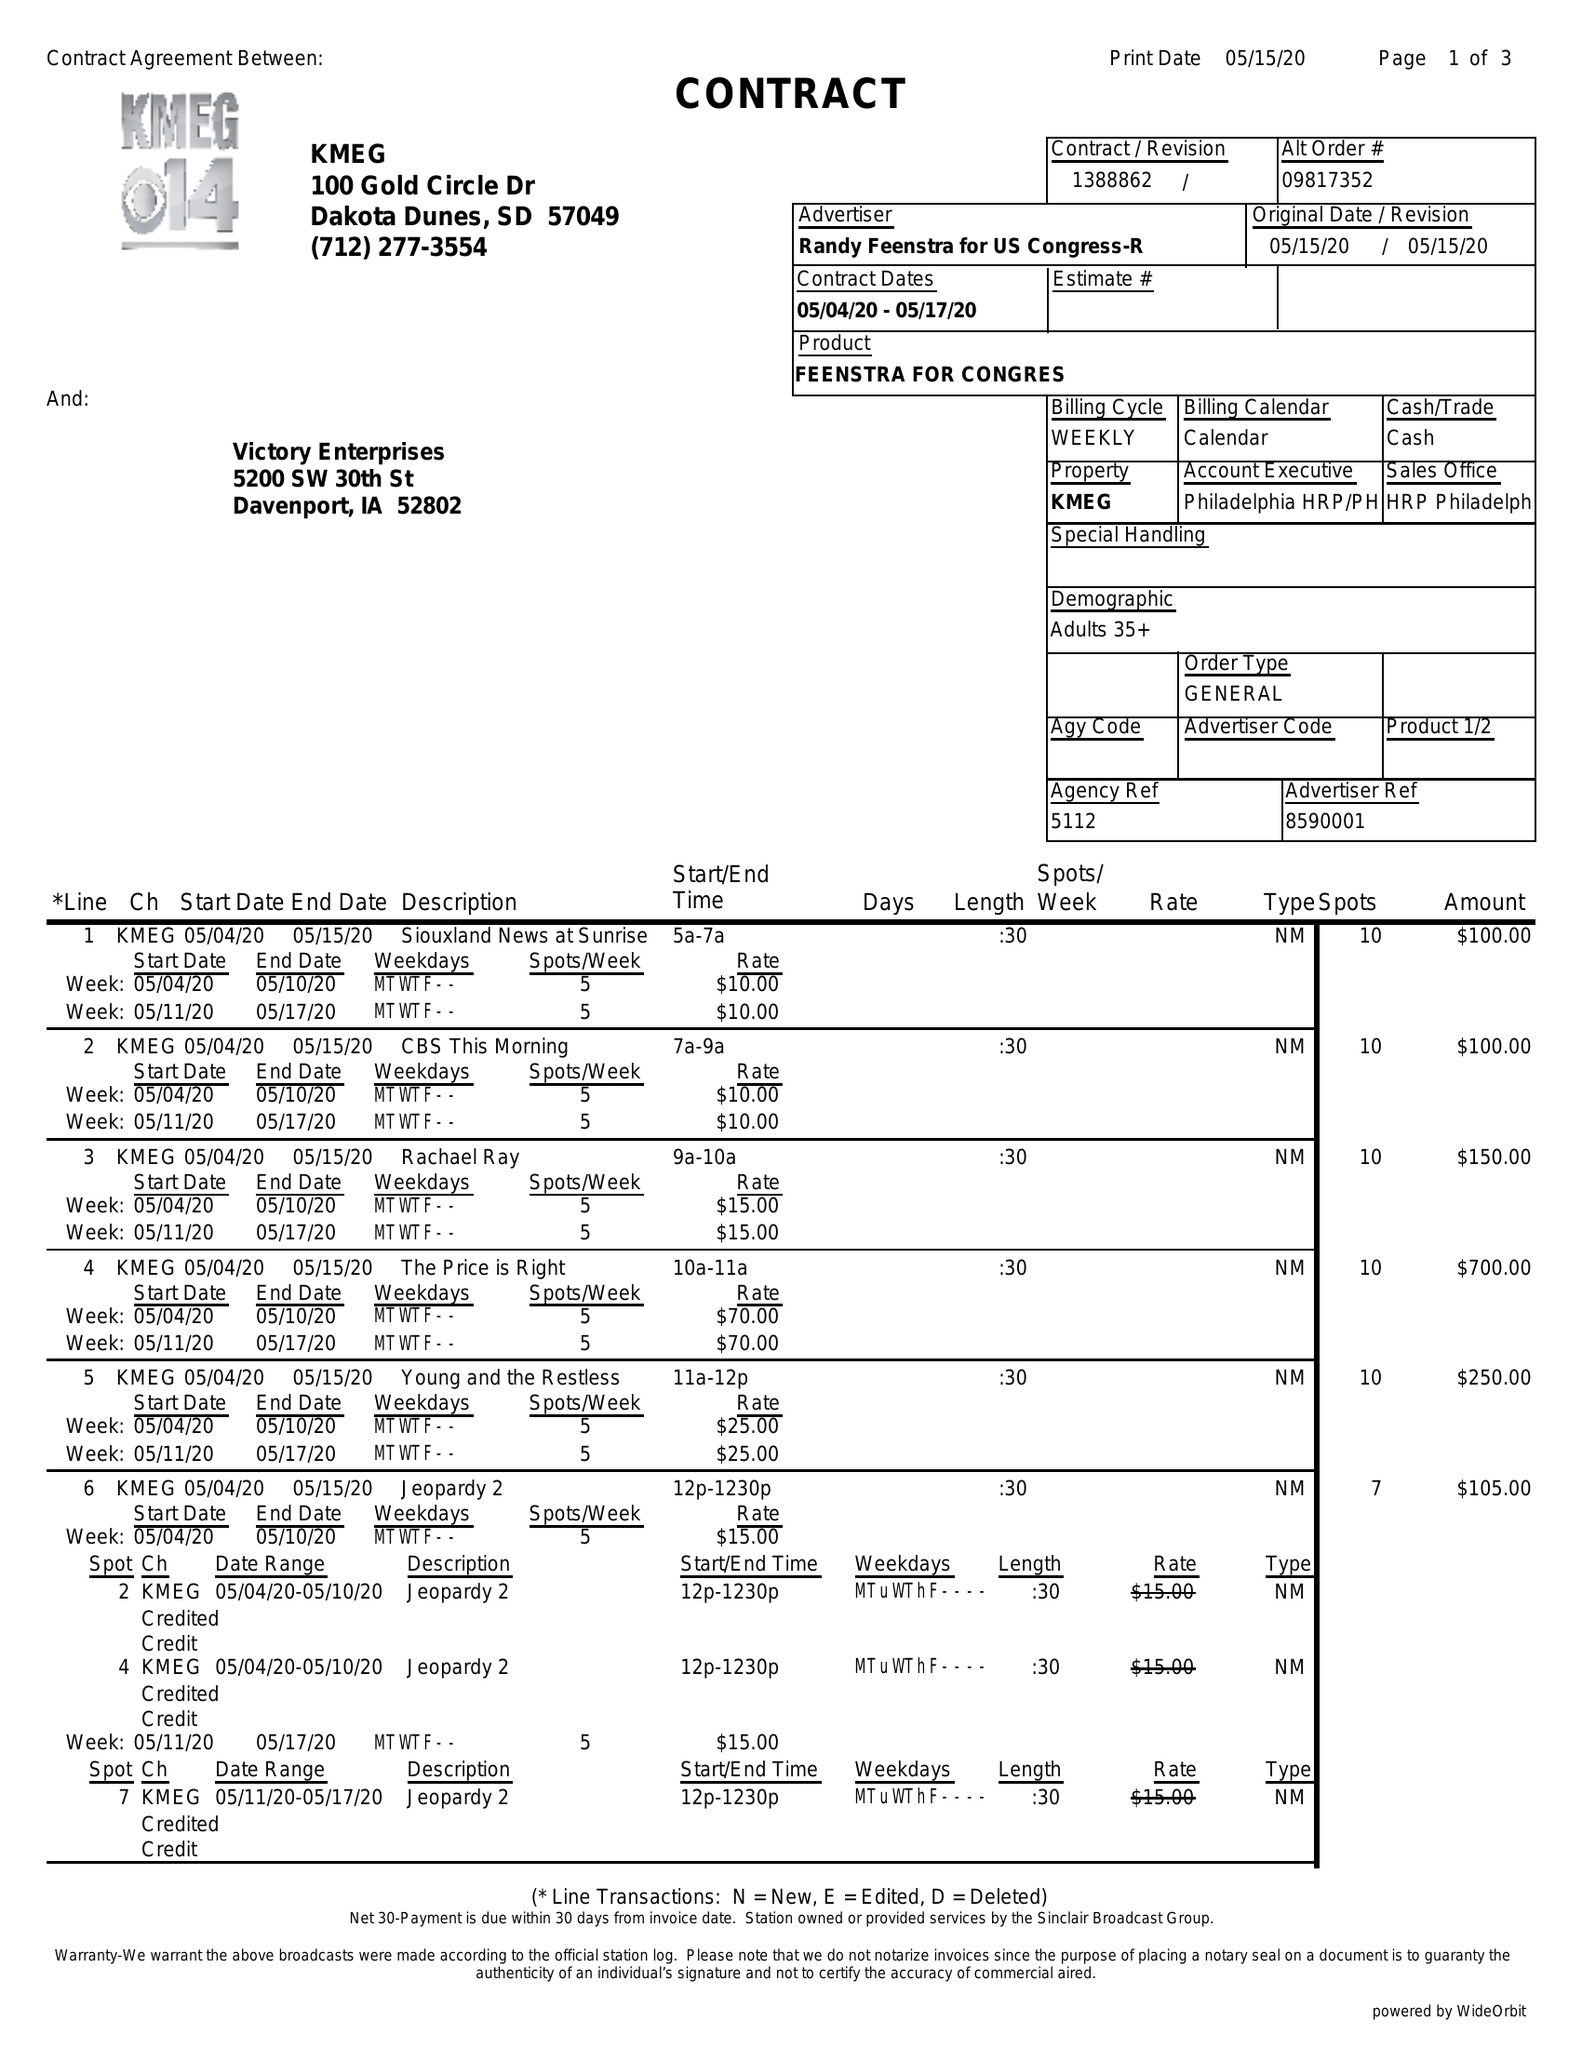What is the value for the contract_num?
Answer the question using a single word or phrase. 1388862 